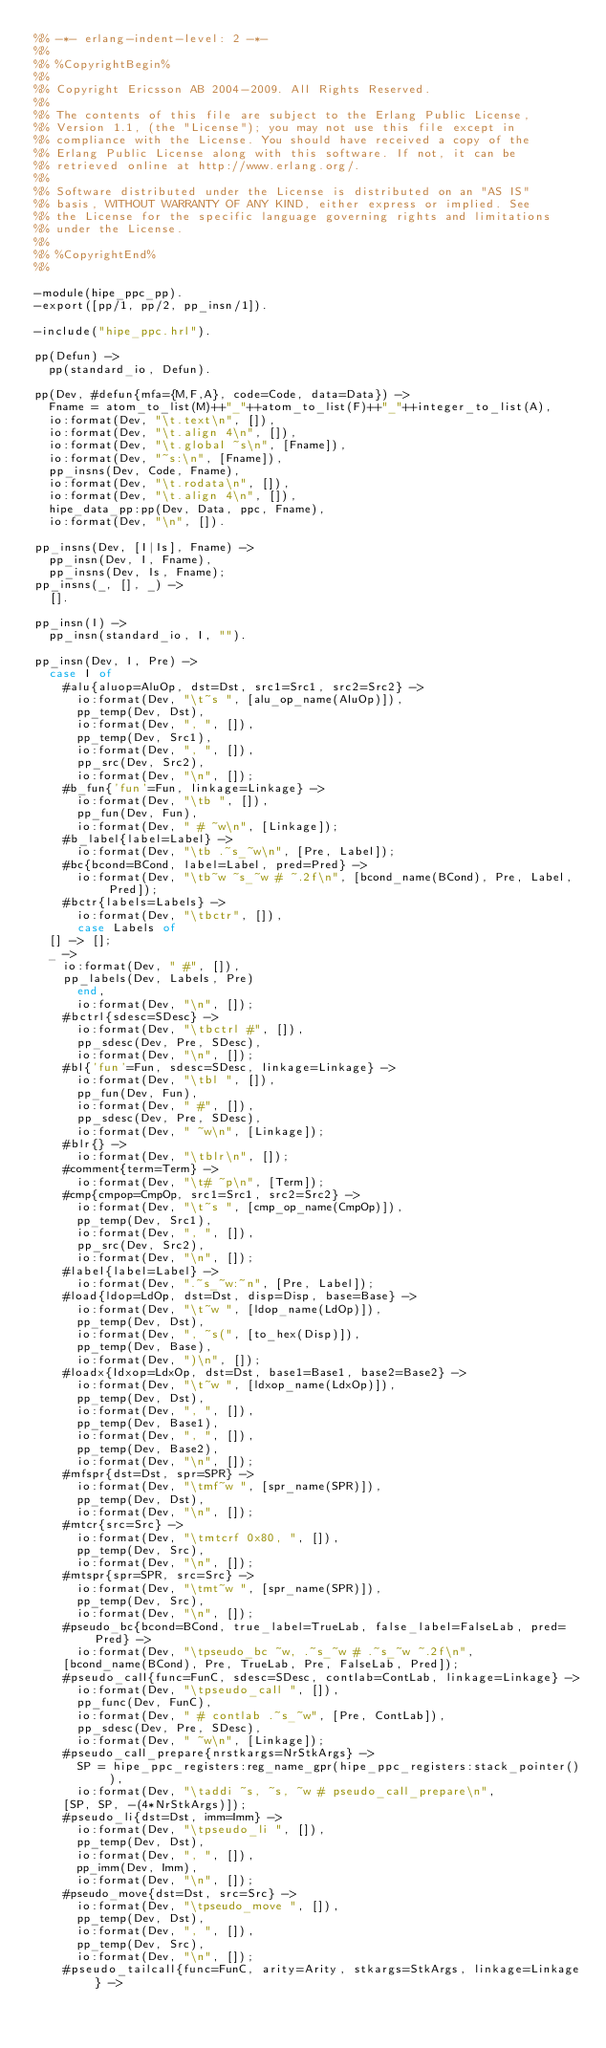Convert code to text. <code><loc_0><loc_0><loc_500><loc_500><_Erlang_>%% -*- erlang-indent-level: 2 -*-
%%
%% %CopyrightBegin%
%% 
%% Copyright Ericsson AB 2004-2009. All Rights Reserved.
%% 
%% The contents of this file are subject to the Erlang Public License,
%% Version 1.1, (the "License"); you may not use this file except in
%% compliance with the License. You should have received a copy of the
%% Erlang Public License along with this software. If not, it can be
%% retrieved online at http://www.erlang.org/.
%% 
%% Software distributed under the License is distributed on an "AS IS"
%% basis, WITHOUT WARRANTY OF ANY KIND, either express or implied. See
%% the License for the specific language governing rights and limitations
%% under the License.
%% 
%% %CopyrightEnd%
%%

-module(hipe_ppc_pp).
-export([pp/1, pp/2, pp_insn/1]).

-include("hipe_ppc.hrl").

pp(Defun) ->
  pp(standard_io, Defun).

pp(Dev, #defun{mfa={M,F,A}, code=Code, data=Data}) ->
  Fname = atom_to_list(M)++"_"++atom_to_list(F)++"_"++integer_to_list(A),
  io:format(Dev, "\t.text\n", []),
  io:format(Dev, "\t.align 4\n", []),
  io:format(Dev, "\t.global ~s\n", [Fname]),
  io:format(Dev, "~s:\n", [Fname]),
  pp_insns(Dev, Code, Fname),
  io:format(Dev, "\t.rodata\n", []),
  io:format(Dev, "\t.align 4\n", []),
  hipe_data_pp:pp(Dev, Data, ppc, Fname),
  io:format(Dev, "\n", []).

pp_insns(Dev, [I|Is], Fname) ->
  pp_insn(Dev, I, Fname),
  pp_insns(Dev, Is, Fname);
pp_insns(_, [], _) ->
  [].

pp_insn(I) ->
  pp_insn(standard_io, I, "").

pp_insn(Dev, I, Pre) ->
  case I of
    #alu{aluop=AluOp, dst=Dst, src1=Src1, src2=Src2} ->
      io:format(Dev, "\t~s ", [alu_op_name(AluOp)]),
      pp_temp(Dev, Dst),
      io:format(Dev, ", ", []),
      pp_temp(Dev, Src1),
      io:format(Dev, ", ", []),
      pp_src(Dev, Src2),
      io:format(Dev, "\n", []);
    #b_fun{'fun'=Fun, linkage=Linkage} ->
      io:format(Dev, "\tb ", []),
      pp_fun(Dev, Fun),
      io:format(Dev, " # ~w\n", [Linkage]);
    #b_label{label=Label} ->
      io:format(Dev, "\tb .~s_~w\n", [Pre, Label]);
    #bc{bcond=BCond, label=Label, pred=Pred} ->
      io:format(Dev, "\tb~w ~s_~w # ~.2f\n", [bcond_name(BCond), Pre, Label, Pred]);
    #bctr{labels=Labels} ->
      io:format(Dev, "\tbctr", []),
      case Labels of
	[] -> [];
	_ ->
	  io:format(Dev, " #", []),
	  pp_labels(Dev, Labels, Pre)
      end,
      io:format(Dev, "\n", []);
    #bctrl{sdesc=SDesc} ->
      io:format(Dev, "\tbctrl #", []),
      pp_sdesc(Dev, Pre, SDesc),
      io:format(Dev, "\n", []);
    #bl{'fun'=Fun, sdesc=SDesc, linkage=Linkage} ->
      io:format(Dev, "\tbl ", []),
      pp_fun(Dev, Fun),
      io:format(Dev, " #", []),
      pp_sdesc(Dev, Pre, SDesc),
      io:format(Dev, " ~w\n", [Linkage]);
    #blr{} ->
      io:format(Dev, "\tblr\n", []);
    #comment{term=Term} ->
      io:format(Dev, "\t# ~p\n", [Term]);
    #cmp{cmpop=CmpOp, src1=Src1, src2=Src2} ->
      io:format(Dev, "\t~s ", [cmp_op_name(CmpOp)]),
      pp_temp(Dev, Src1),
      io:format(Dev, ", ", []),
      pp_src(Dev, Src2),
      io:format(Dev, "\n", []);
    #label{label=Label} ->
      io:format(Dev, ".~s_~w:~n", [Pre, Label]);
    #load{ldop=LdOp, dst=Dst, disp=Disp, base=Base} ->
      io:format(Dev, "\t~w ", [ldop_name(LdOp)]),
      pp_temp(Dev, Dst),
      io:format(Dev, ", ~s(", [to_hex(Disp)]),
      pp_temp(Dev, Base),
      io:format(Dev, ")\n", []);
    #loadx{ldxop=LdxOp, dst=Dst, base1=Base1, base2=Base2} ->
      io:format(Dev, "\t~w ", [ldxop_name(LdxOp)]),
      pp_temp(Dev, Dst),
      io:format(Dev, ", ", []),
      pp_temp(Dev, Base1),
      io:format(Dev, ", ", []),
      pp_temp(Dev, Base2),
      io:format(Dev, "\n", []);
    #mfspr{dst=Dst, spr=SPR} ->
      io:format(Dev, "\tmf~w ", [spr_name(SPR)]),
      pp_temp(Dev, Dst),
      io:format(Dev, "\n", []);
    #mtcr{src=Src} ->
      io:format(Dev, "\tmtcrf 0x80, ", []),
      pp_temp(Dev, Src),
      io:format(Dev, "\n", []);
    #mtspr{spr=SPR, src=Src} ->
      io:format(Dev, "\tmt~w ", [spr_name(SPR)]),
      pp_temp(Dev, Src),
      io:format(Dev, "\n", []);
    #pseudo_bc{bcond=BCond, true_label=TrueLab, false_label=FalseLab, pred=Pred} ->
      io:format(Dev, "\tpseudo_bc ~w, .~s_~w # .~s_~w ~.2f\n",
		[bcond_name(BCond), Pre, TrueLab, Pre, FalseLab, Pred]);
    #pseudo_call{func=FunC, sdesc=SDesc, contlab=ContLab, linkage=Linkage} ->
      io:format(Dev, "\tpseudo_call ", []),
      pp_func(Dev, FunC),
      io:format(Dev, " # contlab .~s_~w", [Pre, ContLab]),
      pp_sdesc(Dev, Pre, SDesc),
      io:format(Dev, " ~w\n", [Linkage]);
    #pseudo_call_prepare{nrstkargs=NrStkArgs} ->
      SP = hipe_ppc_registers:reg_name_gpr(hipe_ppc_registers:stack_pointer()),
      io:format(Dev, "\taddi ~s, ~s, ~w # pseudo_call_prepare\n",
		[SP, SP, -(4*NrStkArgs)]);
    #pseudo_li{dst=Dst, imm=Imm} ->
      io:format(Dev, "\tpseudo_li ", []),
      pp_temp(Dev, Dst),
      io:format(Dev, ", ", []),
      pp_imm(Dev, Imm),
      io:format(Dev, "\n", []);
    #pseudo_move{dst=Dst, src=Src} ->
      io:format(Dev, "\tpseudo_move ", []),
      pp_temp(Dev, Dst),
      io:format(Dev, ", ", []),
      pp_temp(Dev, Src),
      io:format(Dev, "\n", []);
    #pseudo_tailcall{func=FunC, arity=Arity, stkargs=StkArgs, linkage=Linkage} -></code> 